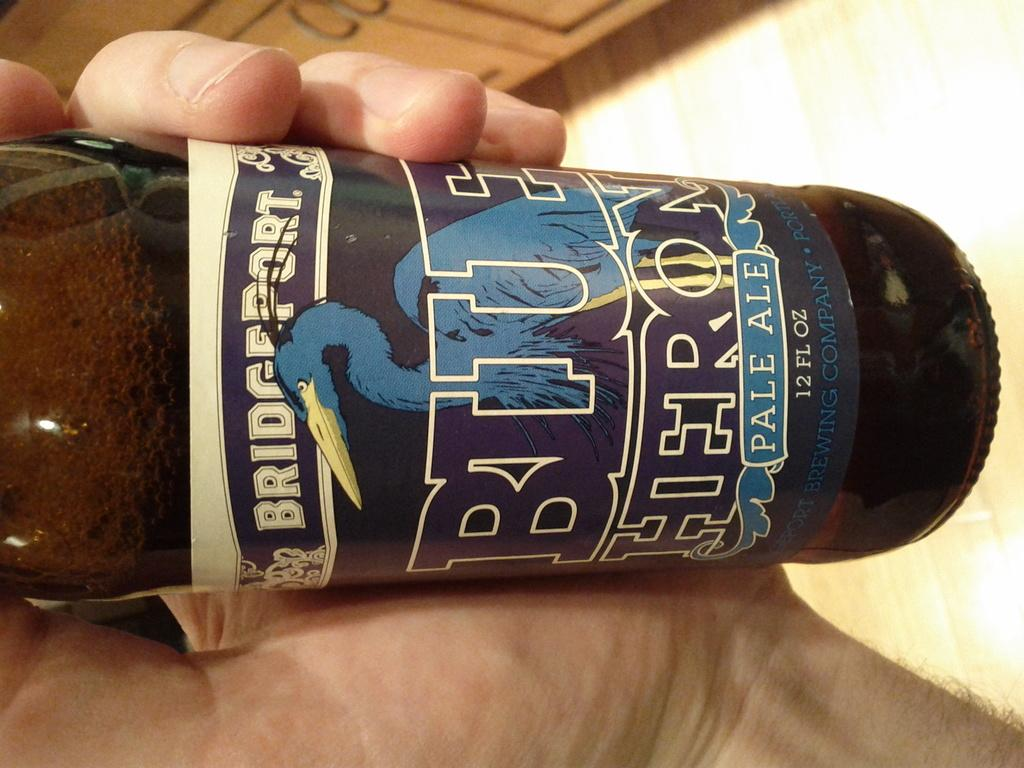<image>
Relay a brief, clear account of the picture shown. A bottle of Bridegport Blue Pale Ale beer being held in a man's hand. 